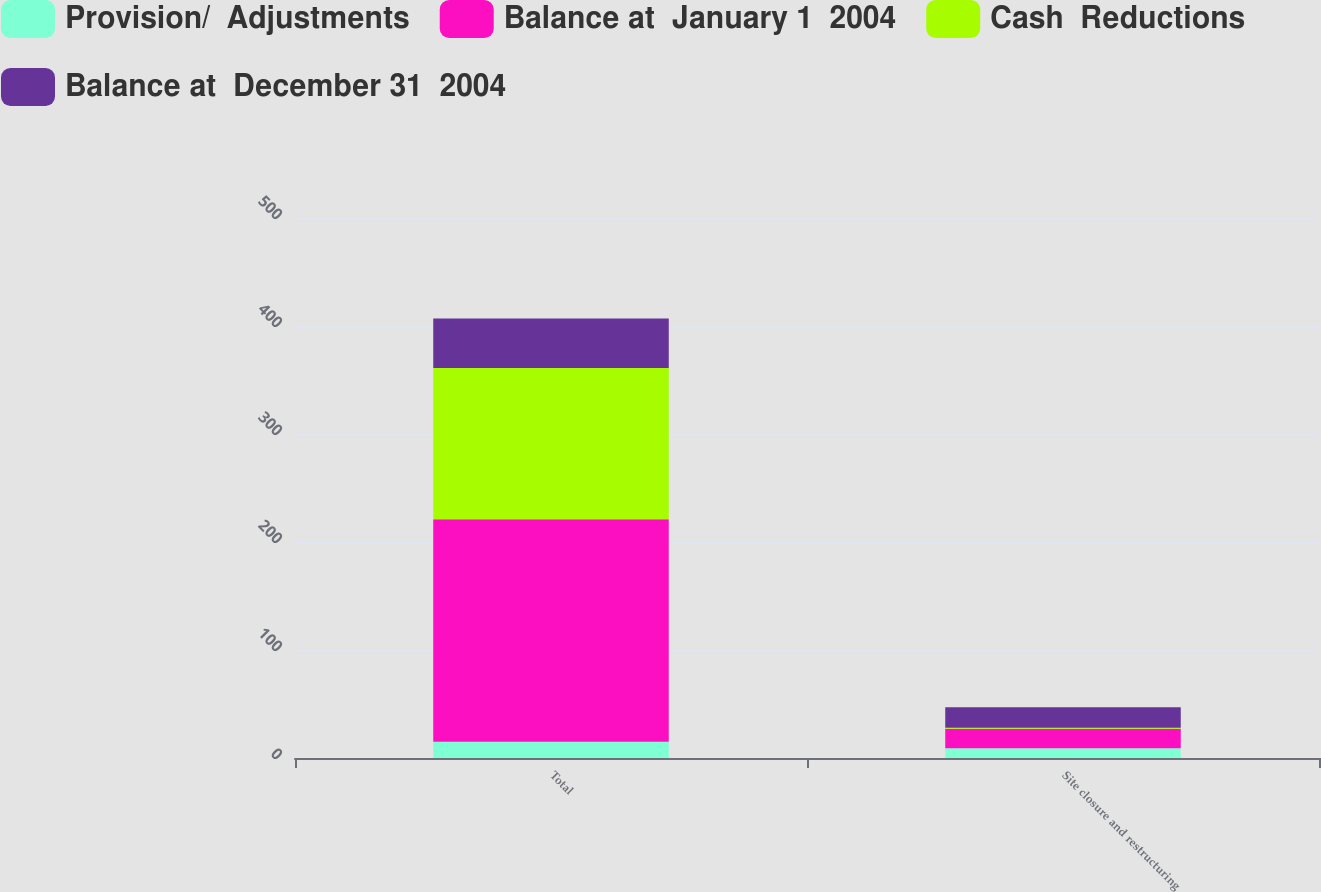Convert chart. <chart><loc_0><loc_0><loc_500><loc_500><stacked_bar_chart><ecel><fcel>Total<fcel>Site closure and restructuring<nl><fcel>Provision/  Adjustments<fcel>15<fcel>9<nl><fcel>Balance at  January 1  2004<fcel>206<fcel>18<nl><fcel>Cash  Reductions<fcel>140<fcel>1<nl><fcel>Balance at  December 31  2004<fcel>46<fcel>19<nl></chart> 